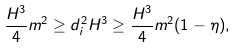<formula> <loc_0><loc_0><loc_500><loc_500>\frac { H ^ { 3 } } { 4 } m ^ { 2 } \geq d _ { i } ^ { 2 } H ^ { 3 } \geq \frac { H ^ { 3 } } { 4 } m ^ { 2 } ( 1 - \eta ) ,</formula> 